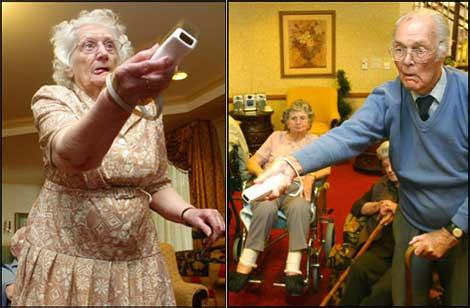Is the woman behind the man in a wheelchair?
Be succinct. Yes. What kind of home does the man on the left live in?
Short answer required. Nursing home. Are these senior citizens?
Write a very short answer. Yes. 